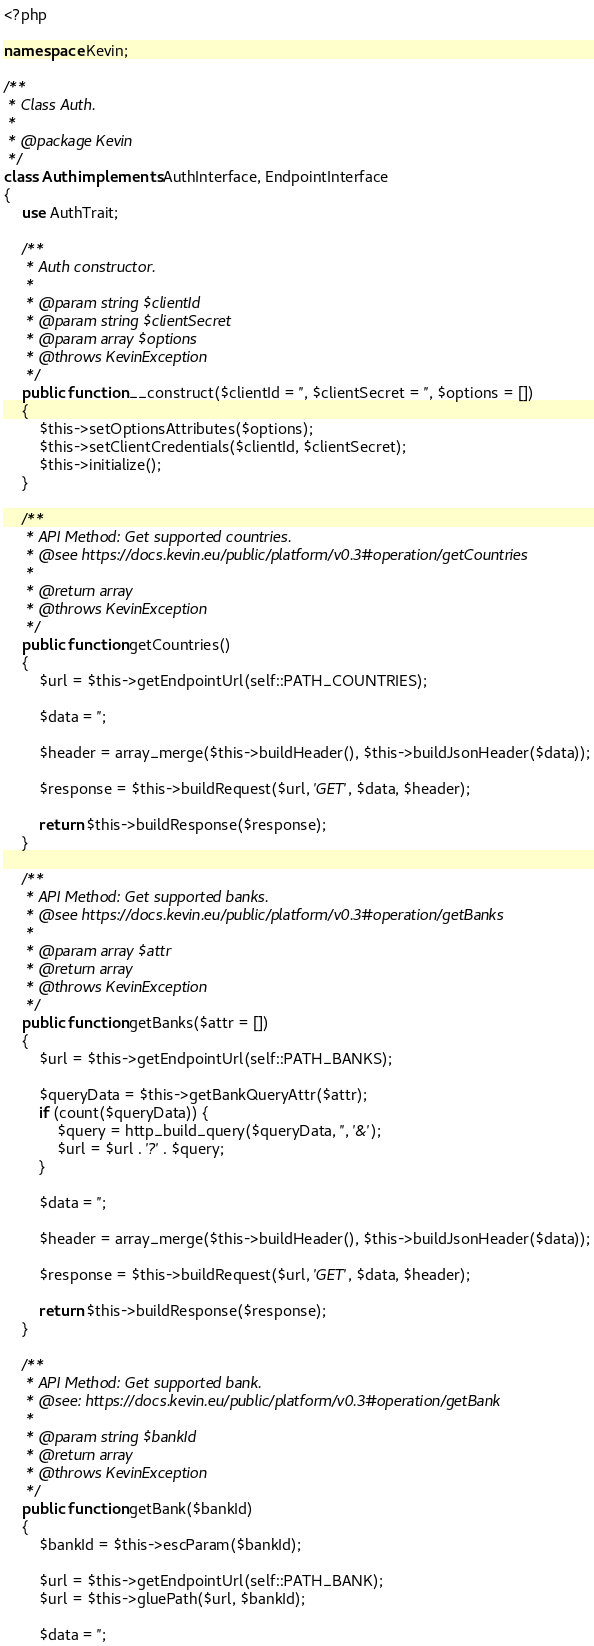<code> <loc_0><loc_0><loc_500><loc_500><_PHP_><?php

namespace Kevin;

/**
 * Class Auth.
 *
 * @package Kevin
 */
class Auth implements AuthInterface, EndpointInterface
{
    use AuthTrait;

    /**
     * Auth constructor.
     *
     * @param string $clientId
     * @param string $clientSecret
     * @param array $options
     * @throws KevinException
     */
    public function __construct($clientId = '', $clientSecret = '', $options = [])
    {
        $this->setOptionsAttributes($options);
        $this->setClientCredentials($clientId, $clientSecret);
        $this->initialize();
    }

    /**
     * API Method: Get supported countries.
     * @see https://docs.kevin.eu/public/platform/v0.3#operation/getCountries
     *
     * @return array
     * @throws KevinException
     */
    public function getCountries()
    {
        $url = $this->getEndpointUrl(self::PATH_COUNTRIES);

        $data = '';

        $header = array_merge($this->buildHeader(), $this->buildJsonHeader($data));

        $response = $this->buildRequest($url, 'GET', $data, $header);

        return $this->buildResponse($response);
    }

    /**
     * API Method: Get supported banks.
     * @see https://docs.kevin.eu/public/platform/v0.3#operation/getBanks
     *
     * @param array $attr
     * @return array
     * @throws KevinException
     */
    public function getBanks($attr = [])
    {
        $url = $this->getEndpointUrl(self::PATH_BANKS);

        $queryData = $this->getBankQueryAttr($attr);
        if (count($queryData)) {
            $query = http_build_query($queryData, '', '&');
            $url = $url . '?' . $query;
        }

        $data = '';

        $header = array_merge($this->buildHeader(), $this->buildJsonHeader($data));

        $response = $this->buildRequest($url, 'GET', $data, $header);

        return $this->buildResponse($response);
    }

    /**
     * API Method: Get supported bank.
     * @see: https://docs.kevin.eu/public/platform/v0.3#operation/getBank
     *
     * @param string $bankId
     * @return array
     * @throws KevinException
     */
    public function getBank($bankId)
    {
        $bankId = $this->escParam($bankId);

        $url = $this->getEndpointUrl(self::PATH_BANK);
        $url = $this->gluePath($url, $bankId);

        $data = '';
</code> 